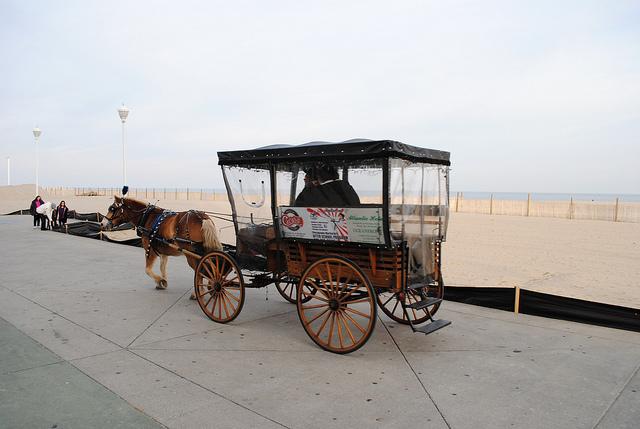What is the purpose of this trailer?
Be succinct. Transportation. Was this taken near a beach?
Keep it brief. Yes. What is pulling the carriage?
Write a very short answer. Horse. How many wheels do these items have?
Write a very short answer. 4. How many horses are pulling the cart?
Answer briefly. 1. Is the carriage enclosed?
Be succinct. Yes. What color is the wagon?
Write a very short answer. Brown. How many wheels is on the carriage?
Be succinct. 4. How many horses are in the photo?
Short answer required. 1. Are there fruits or vegetables are the cart?
Concise answer only. No. How many spokes are on the wooden wheel?
Write a very short answer. 16. 